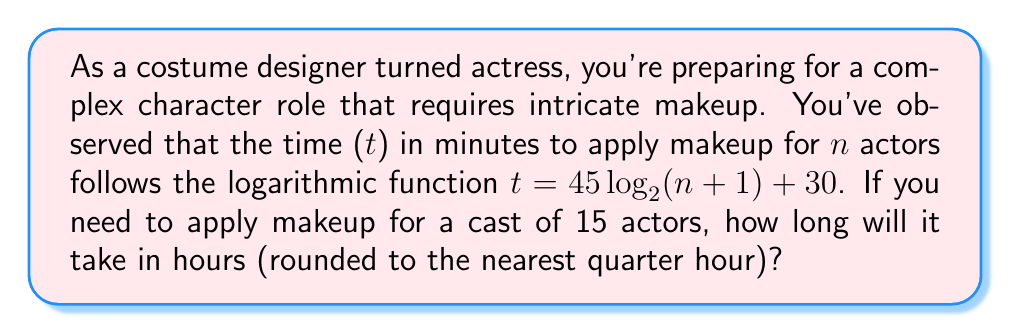Solve this math problem. Let's approach this step-by-step:

1) We're given the function $t = 45 \log_2(n+1) + 30$, where t is time in minutes and n is the number of actors.

2) We need to find t when n = 15:
   $t = 45 \log_2(15+1) + 30$
   $t = 45 \log_2(16) + 30$

3) Simplify $\log_2(16)$:
   $\log_2(16) = 4$ (because $2^4 = 16$)

4) Now we can calculate t:
   $t = 45 \cdot 4 + 30$
   $t = 180 + 30 = 210$ minutes

5) Convert 210 minutes to hours:
   $210 \div 60 = 3.5$ hours

6) Rounding 3.5 hours to the nearest quarter hour:
   3.5 hours rounds to 3.5 hours (it's already a quarter hour)

Therefore, it will take 3.5 hours to apply makeup for 15 actors.
Answer: 3.5 hours 